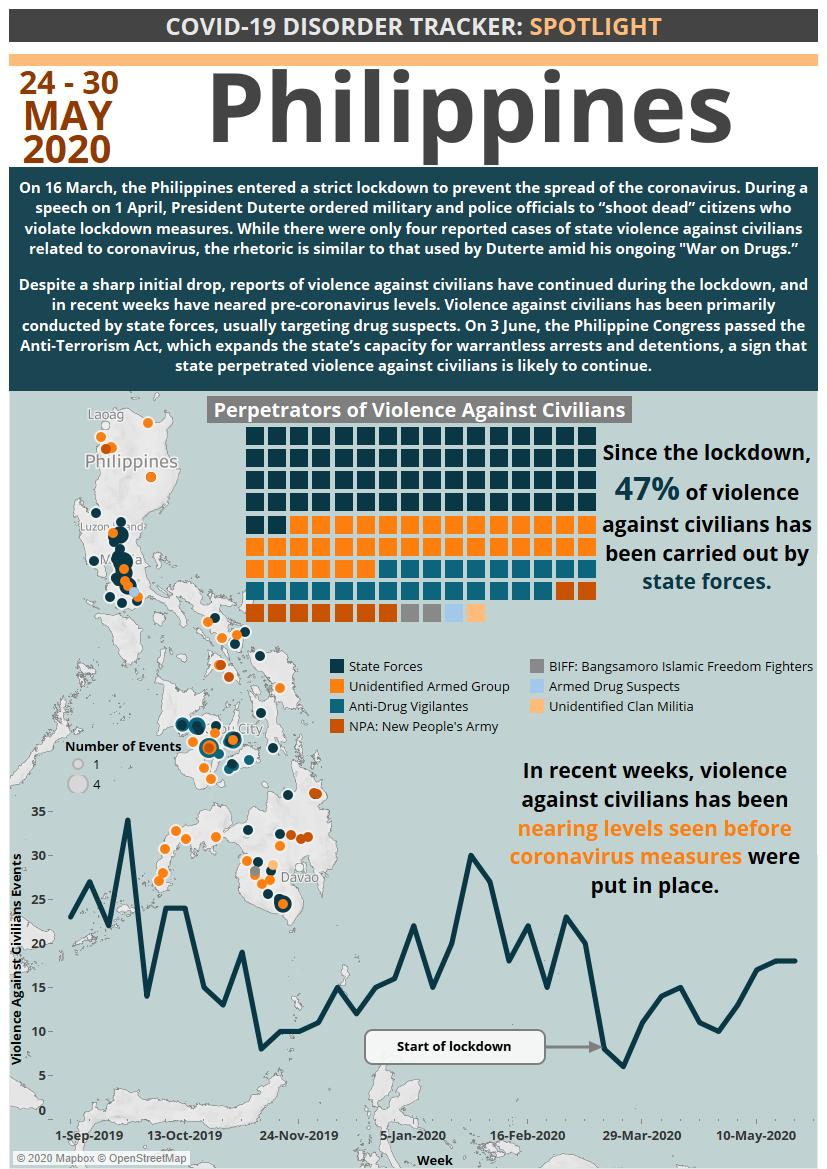Mention a couple of crucial points in this snapshot. The armed drug suspects and the unidentified clan militia were responsible for the lowest number of violence cases. The second highest number of violence cases against citizens was committed by an unidentified armed group. 